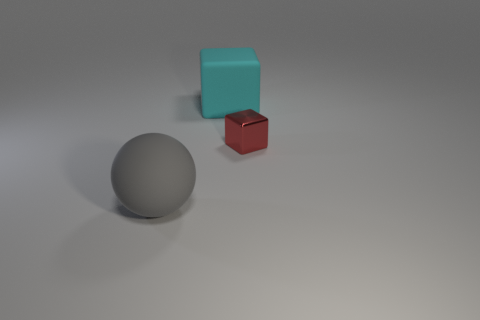Is there anything else that has the same material as the tiny block?
Your answer should be compact. No. Are the ball and the large thing that is behind the small metal object made of the same material?
Your answer should be compact. Yes. Is the number of matte blocks in front of the small cube less than the number of rubber things to the right of the big gray object?
Ensure brevity in your answer.  Yes. There is a thing behind the small red block; what material is it?
Make the answer very short. Rubber. What color is the thing that is both to the right of the large gray thing and in front of the big rubber cube?
Provide a short and direct response. Red. How many other objects are there of the same color as the tiny block?
Provide a short and direct response. 0. What is the color of the thing behind the red object?
Your answer should be very brief. Cyan. Is there a gray shiny object that has the same size as the cyan rubber block?
Provide a succinct answer. No. What material is the cube that is the same size as the gray sphere?
Offer a terse response. Rubber. What number of things are either rubber objects that are in front of the tiny red object or objects in front of the red metallic cube?
Keep it short and to the point. 1. 